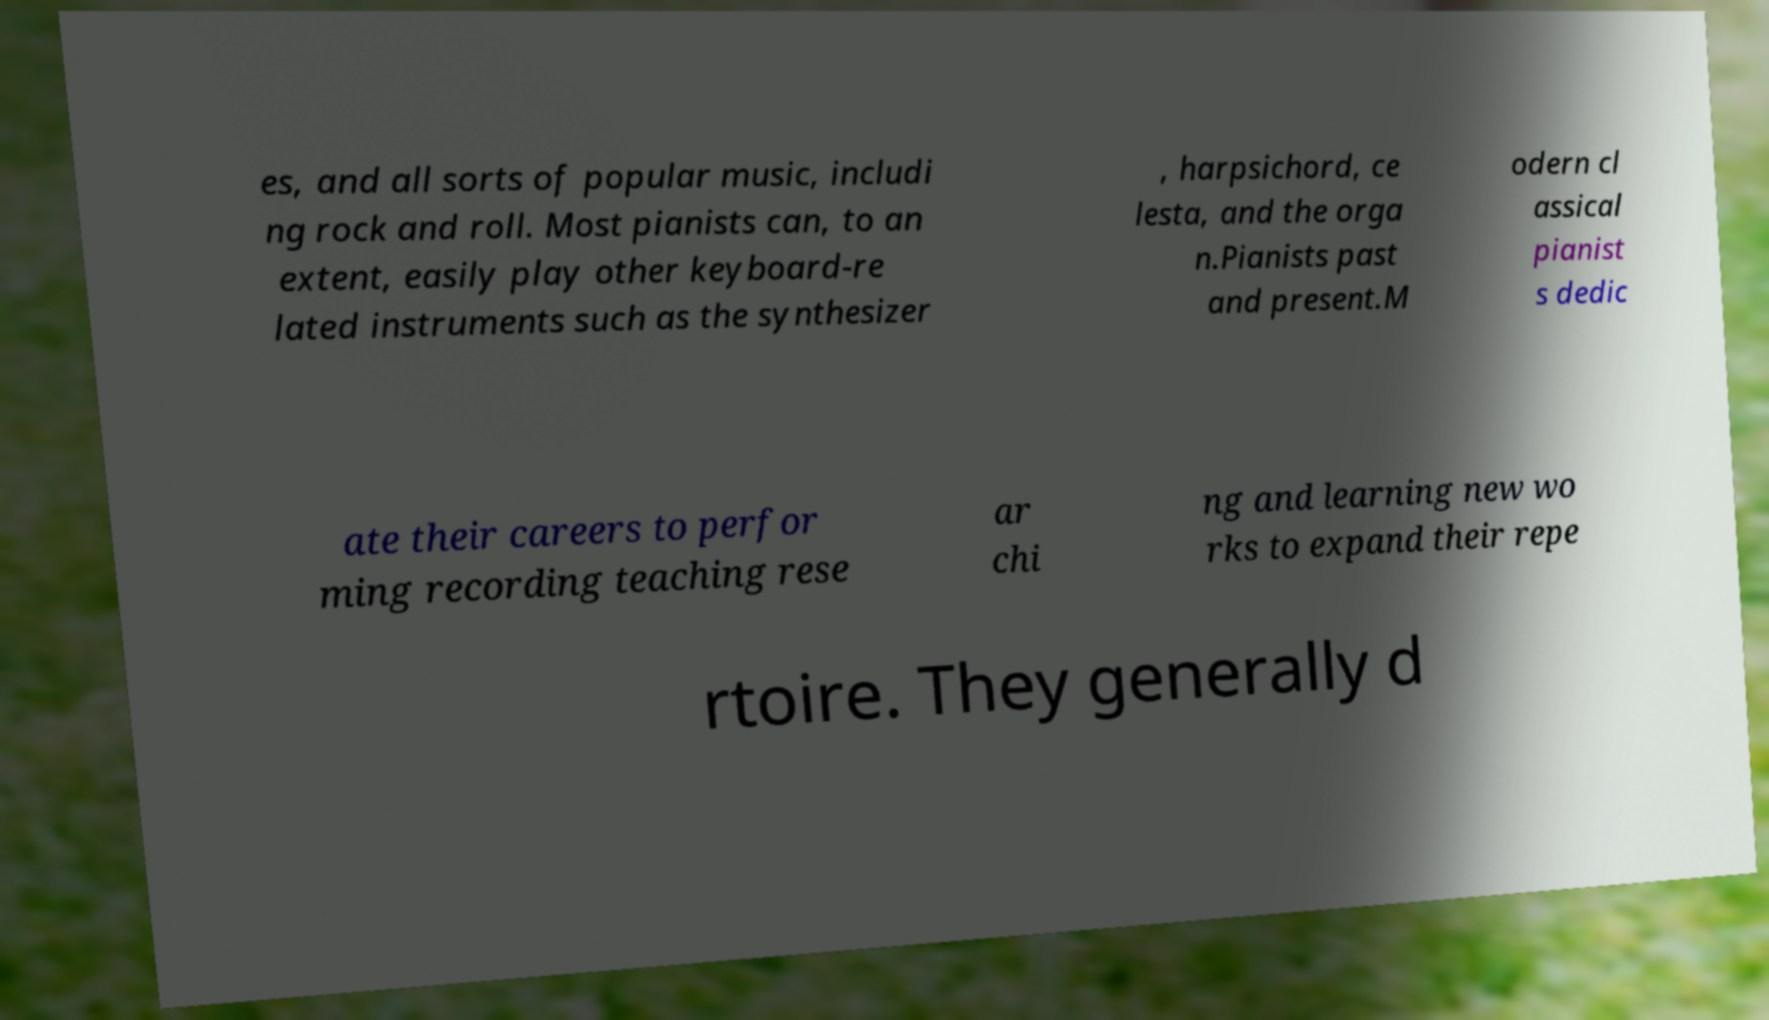I need the written content from this picture converted into text. Can you do that? es, and all sorts of popular music, includi ng rock and roll. Most pianists can, to an extent, easily play other keyboard-re lated instruments such as the synthesizer , harpsichord, ce lesta, and the orga n.Pianists past and present.M odern cl assical pianist s dedic ate their careers to perfor ming recording teaching rese ar chi ng and learning new wo rks to expand their repe rtoire. They generally d 